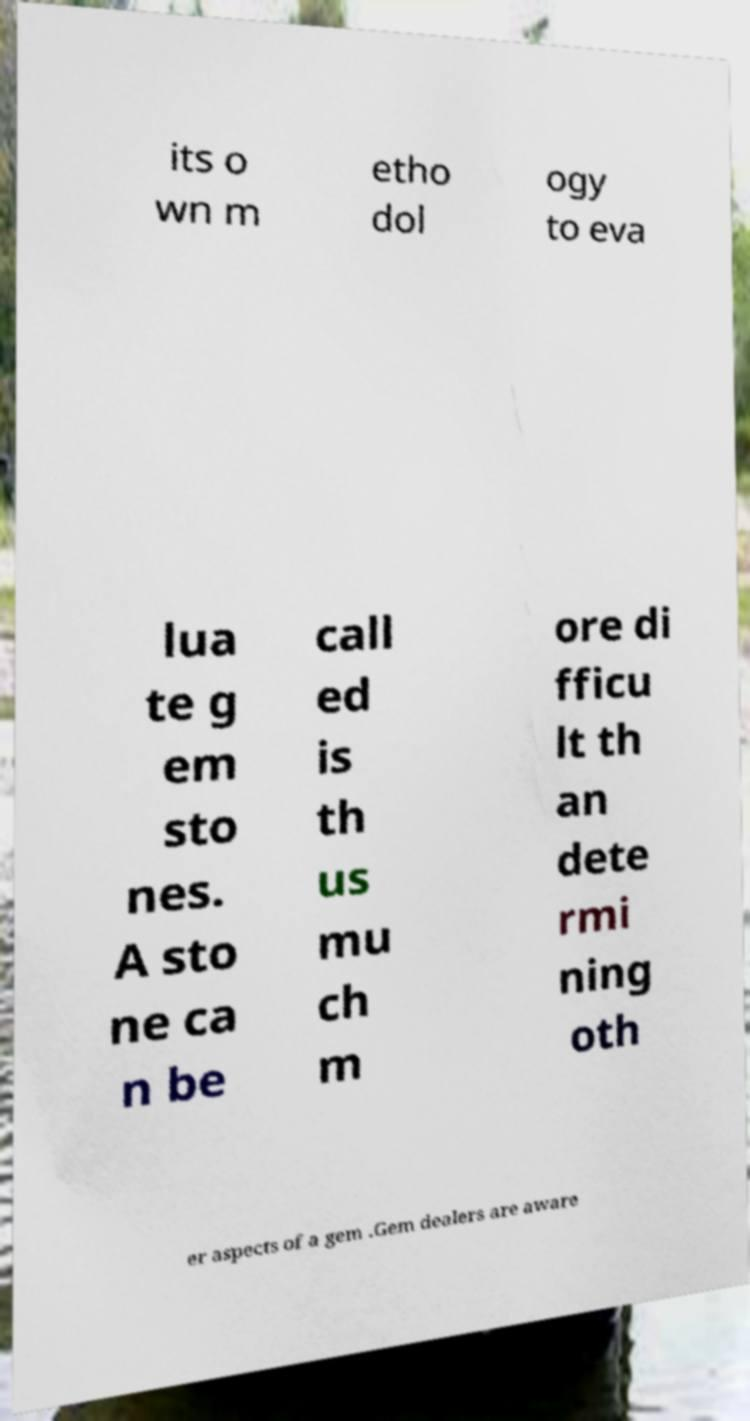Can you accurately transcribe the text from the provided image for me? its o wn m etho dol ogy to eva lua te g em sto nes. A sto ne ca n be call ed is th us mu ch m ore di fficu lt th an dete rmi ning oth er aspects of a gem .Gem dealers are aware 